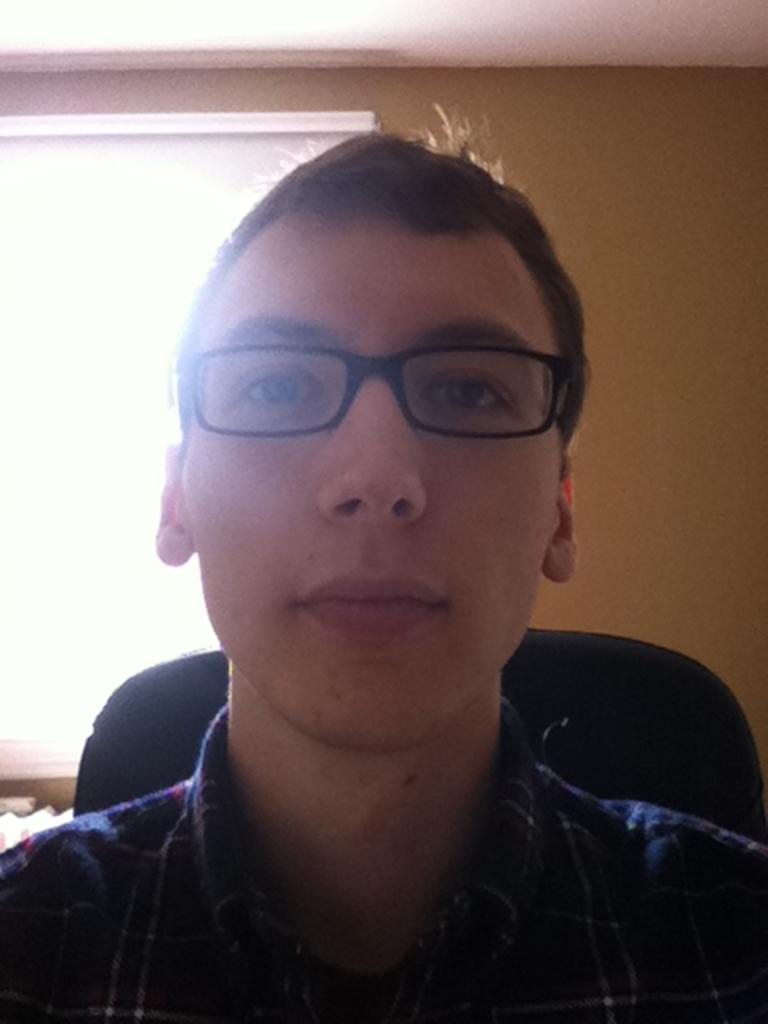What is the main subject of the image? There is a person in the image. What can be seen on the person's face? The person is wearing specs. What is the person doing in the image? The person is sitting on a chair. What is the color of the chair? The chair is black in color. What can be seen in the background of the image? There is a window in the background of the image. What type of education is being protested by the robin in the image? There is no robin or protest present in the image. What type of bird is sitting on the person's shoulder in the image? There is no bird present in the image. 